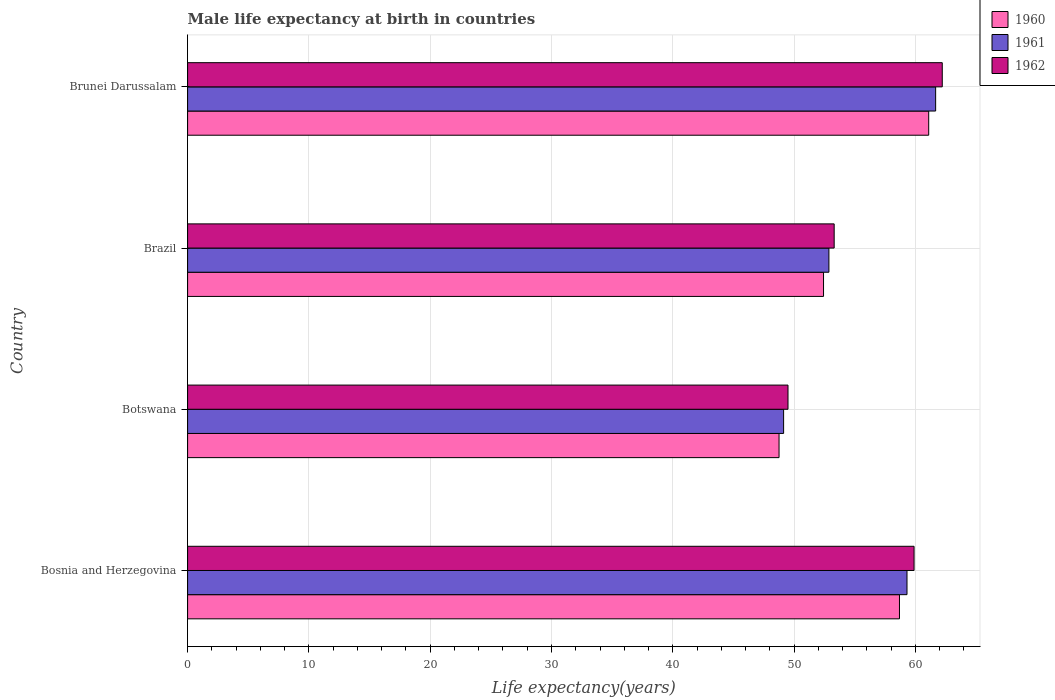How many different coloured bars are there?
Make the answer very short. 3. Are the number of bars on each tick of the Y-axis equal?
Keep it short and to the point. Yes. How many bars are there on the 1st tick from the top?
Offer a terse response. 3. How many bars are there on the 2nd tick from the bottom?
Offer a terse response. 3. What is the label of the 2nd group of bars from the top?
Keep it short and to the point. Brazil. What is the male life expectancy at birth in 1960 in Botswana?
Offer a very short reply. 48.76. Across all countries, what is the maximum male life expectancy at birth in 1960?
Your response must be concise. 61.09. Across all countries, what is the minimum male life expectancy at birth in 1962?
Offer a very short reply. 49.5. In which country was the male life expectancy at birth in 1962 maximum?
Your response must be concise. Brunei Darussalam. In which country was the male life expectancy at birth in 1960 minimum?
Provide a short and direct response. Botswana. What is the total male life expectancy at birth in 1962 in the graph?
Offer a terse response. 224.9. What is the difference between the male life expectancy at birth in 1961 in Bosnia and Herzegovina and that in Brunei Darussalam?
Offer a very short reply. -2.36. What is the difference between the male life expectancy at birth in 1960 in Brunei Darussalam and the male life expectancy at birth in 1961 in Brazil?
Ensure brevity in your answer.  8.23. What is the average male life expectancy at birth in 1960 per country?
Provide a succinct answer. 55.24. What is the difference between the male life expectancy at birth in 1961 and male life expectancy at birth in 1962 in Bosnia and Herzegovina?
Your answer should be very brief. -0.58. What is the ratio of the male life expectancy at birth in 1960 in Brazil to that in Brunei Darussalam?
Your answer should be compact. 0.86. What is the difference between the highest and the second highest male life expectancy at birth in 1960?
Your answer should be very brief. 2.41. What is the difference between the highest and the lowest male life expectancy at birth in 1961?
Make the answer very short. 12.53. In how many countries, is the male life expectancy at birth in 1960 greater than the average male life expectancy at birth in 1960 taken over all countries?
Offer a very short reply. 2. Is the sum of the male life expectancy at birth in 1962 in Brazil and Brunei Darussalam greater than the maximum male life expectancy at birth in 1961 across all countries?
Give a very brief answer. Yes. What does the 2nd bar from the bottom in Brunei Darussalam represents?
Provide a short and direct response. 1961. Are the values on the major ticks of X-axis written in scientific E-notation?
Ensure brevity in your answer.  No. How are the legend labels stacked?
Give a very brief answer. Vertical. What is the title of the graph?
Make the answer very short. Male life expectancy at birth in countries. What is the label or title of the X-axis?
Give a very brief answer. Life expectancy(years). What is the label or title of the Y-axis?
Your answer should be very brief. Country. What is the Life expectancy(years) of 1960 in Bosnia and Herzegovina?
Offer a very short reply. 58.69. What is the Life expectancy(years) of 1961 in Bosnia and Herzegovina?
Your answer should be very brief. 59.3. What is the Life expectancy(years) in 1962 in Bosnia and Herzegovina?
Your answer should be very brief. 59.89. What is the Life expectancy(years) of 1960 in Botswana?
Keep it short and to the point. 48.76. What is the Life expectancy(years) of 1961 in Botswana?
Make the answer very short. 49.13. What is the Life expectancy(years) of 1962 in Botswana?
Your answer should be very brief. 49.5. What is the Life expectancy(years) in 1960 in Brazil?
Your answer should be very brief. 52.42. What is the Life expectancy(years) of 1961 in Brazil?
Ensure brevity in your answer.  52.87. What is the Life expectancy(years) of 1962 in Brazil?
Your answer should be compact. 53.3. What is the Life expectancy(years) in 1960 in Brunei Darussalam?
Provide a succinct answer. 61.09. What is the Life expectancy(years) in 1961 in Brunei Darussalam?
Provide a short and direct response. 61.67. What is the Life expectancy(years) of 1962 in Brunei Darussalam?
Ensure brevity in your answer.  62.21. Across all countries, what is the maximum Life expectancy(years) in 1960?
Provide a short and direct response. 61.09. Across all countries, what is the maximum Life expectancy(years) of 1961?
Keep it short and to the point. 61.67. Across all countries, what is the maximum Life expectancy(years) of 1962?
Offer a very short reply. 62.21. Across all countries, what is the minimum Life expectancy(years) of 1960?
Ensure brevity in your answer.  48.76. Across all countries, what is the minimum Life expectancy(years) in 1961?
Offer a very short reply. 49.13. Across all countries, what is the minimum Life expectancy(years) of 1962?
Ensure brevity in your answer.  49.5. What is the total Life expectancy(years) of 1960 in the graph?
Offer a very short reply. 220.96. What is the total Life expectancy(years) in 1961 in the graph?
Keep it short and to the point. 222.97. What is the total Life expectancy(years) of 1962 in the graph?
Give a very brief answer. 224.9. What is the difference between the Life expectancy(years) of 1960 in Bosnia and Herzegovina and that in Botswana?
Offer a terse response. 9.93. What is the difference between the Life expectancy(years) in 1961 in Bosnia and Herzegovina and that in Botswana?
Keep it short and to the point. 10.17. What is the difference between the Life expectancy(years) in 1962 in Bosnia and Herzegovina and that in Botswana?
Your response must be concise. 10.39. What is the difference between the Life expectancy(years) of 1960 in Bosnia and Herzegovina and that in Brazil?
Offer a terse response. 6.26. What is the difference between the Life expectancy(years) of 1961 in Bosnia and Herzegovina and that in Brazil?
Ensure brevity in your answer.  6.44. What is the difference between the Life expectancy(years) in 1962 in Bosnia and Herzegovina and that in Brazil?
Offer a very short reply. 6.58. What is the difference between the Life expectancy(years) of 1960 in Bosnia and Herzegovina and that in Brunei Darussalam?
Keep it short and to the point. -2.41. What is the difference between the Life expectancy(years) in 1961 in Bosnia and Herzegovina and that in Brunei Darussalam?
Ensure brevity in your answer.  -2.36. What is the difference between the Life expectancy(years) of 1962 in Bosnia and Herzegovina and that in Brunei Darussalam?
Provide a short and direct response. -2.33. What is the difference between the Life expectancy(years) in 1960 in Botswana and that in Brazil?
Offer a very short reply. -3.67. What is the difference between the Life expectancy(years) of 1961 in Botswana and that in Brazil?
Your response must be concise. -3.73. What is the difference between the Life expectancy(years) of 1962 in Botswana and that in Brazil?
Ensure brevity in your answer.  -3.81. What is the difference between the Life expectancy(years) of 1960 in Botswana and that in Brunei Darussalam?
Keep it short and to the point. -12.34. What is the difference between the Life expectancy(years) in 1961 in Botswana and that in Brunei Darussalam?
Give a very brief answer. -12.53. What is the difference between the Life expectancy(years) in 1962 in Botswana and that in Brunei Darussalam?
Ensure brevity in your answer.  -12.72. What is the difference between the Life expectancy(years) of 1960 in Brazil and that in Brunei Darussalam?
Your answer should be compact. -8.67. What is the difference between the Life expectancy(years) in 1961 in Brazil and that in Brunei Darussalam?
Your answer should be compact. -8.8. What is the difference between the Life expectancy(years) in 1962 in Brazil and that in Brunei Darussalam?
Provide a succinct answer. -8.91. What is the difference between the Life expectancy(years) of 1960 in Bosnia and Herzegovina and the Life expectancy(years) of 1961 in Botswana?
Keep it short and to the point. 9.55. What is the difference between the Life expectancy(years) of 1960 in Bosnia and Herzegovina and the Life expectancy(years) of 1962 in Botswana?
Offer a very short reply. 9.19. What is the difference between the Life expectancy(years) in 1961 in Bosnia and Herzegovina and the Life expectancy(years) in 1962 in Botswana?
Offer a very short reply. 9.81. What is the difference between the Life expectancy(years) in 1960 in Bosnia and Herzegovina and the Life expectancy(years) in 1961 in Brazil?
Keep it short and to the point. 5.82. What is the difference between the Life expectancy(years) of 1960 in Bosnia and Herzegovina and the Life expectancy(years) of 1962 in Brazil?
Your response must be concise. 5.38. What is the difference between the Life expectancy(years) of 1961 in Bosnia and Herzegovina and the Life expectancy(years) of 1962 in Brazil?
Your response must be concise. 6. What is the difference between the Life expectancy(years) of 1960 in Bosnia and Herzegovina and the Life expectancy(years) of 1961 in Brunei Darussalam?
Keep it short and to the point. -2.98. What is the difference between the Life expectancy(years) in 1960 in Bosnia and Herzegovina and the Life expectancy(years) in 1962 in Brunei Darussalam?
Your answer should be compact. -3.53. What is the difference between the Life expectancy(years) in 1961 in Bosnia and Herzegovina and the Life expectancy(years) in 1962 in Brunei Darussalam?
Make the answer very short. -2.91. What is the difference between the Life expectancy(years) of 1960 in Botswana and the Life expectancy(years) of 1961 in Brazil?
Your answer should be very brief. -4.11. What is the difference between the Life expectancy(years) of 1960 in Botswana and the Life expectancy(years) of 1962 in Brazil?
Your answer should be compact. -4.54. What is the difference between the Life expectancy(years) of 1961 in Botswana and the Life expectancy(years) of 1962 in Brazil?
Offer a terse response. -4.17. What is the difference between the Life expectancy(years) of 1960 in Botswana and the Life expectancy(years) of 1961 in Brunei Darussalam?
Your answer should be very brief. -12.91. What is the difference between the Life expectancy(years) of 1960 in Botswana and the Life expectancy(years) of 1962 in Brunei Darussalam?
Provide a short and direct response. -13.46. What is the difference between the Life expectancy(years) in 1961 in Botswana and the Life expectancy(years) in 1962 in Brunei Darussalam?
Offer a very short reply. -13.08. What is the difference between the Life expectancy(years) in 1960 in Brazil and the Life expectancy(years) in 1961 in Brunei Darussalam?
Your answer should be compact. -9.24. What is the difference between the Life expectancy(years) of 1960 in Brazil and the Life expectancy(years) of 1962 in Brunei Darussalam?
Give a very brief answer. -9.79. What is the difference between the Life expectancy(years) in 1961 in Brazil and the Life expectancy(years) in 1962 in Brunei Darussalam?
Offer a very short reply. -9.35. What is the average Life expectancy(years) in 1960 per country?
Your answer should be very brief. 55.24. What is the average Life expectancy(years) in 1961 per country?
Offer a very short reply. 55.74. What is the average Life expectancy(years) in 1962 per country?
Provide a short and direct response. 56.22. What is the difference between the Life expectancy(years) of 1960 and Life expectancy(years) of 1961 in Bosnia and Herzegovina?
Keep it short and to the point. -0.62. What is the difference between the Life expectancy(years) in 1960 and Life expectancy(years) in 1962 in Bosnia and Herzegovina?
Your response must be concise. -1.2. What is the difference between the Life expectancy(years) of 1961 and Life expectancy(years) of 1962 in Bosnia and Herzegovina?
Provide a succinct answer. -0.58. What is the difference between the Life expectancy(years) of 1960 and Life expectancy(years) of 1961 in Botswana?
Provide a short and direct response. -0.38. What is the difference between the Life expectancy(years) of 1960 and Life expectancy(years) of 1962 in Botswana?
Your response must be concise. -0.74. What is the difference between the Life expectancy(years) in 1961 and Life expectancy(years) in 1962 in Botswana?
Ensure brevity in your answer.  -0.36. What is the difference between the Life expectancy(years) of 1960 and Life expectancy(years) of 1961 in Brazil?
Offer a terse response. -0.44. What is the difference between the Life expectancy(years) in 1960 and Life expectancy(years) in 1962 in Brazil?
Ensure brevity in your answer.  -0.88. What is the difference between the Life expectancy(years) of 1961 and Life expectancy(years) of 1962 in Brazil?
Your answer should be compact. -0.43. What is the difference between the Life expectancy(years) of 1960 and Life expectancy(years) of 1961 in Brunei Darussalam?
Your answer should be very brief. -0.57. What is the difference between the Life expectancy(years) in 1960 and Life expectancy(years) in 1962 in Brunei Darussalam?
Provide a short and direct response. -1.12. What is the difference between the Life expectancy(years) in 1961 and Life expectancy(years) in 1962 in Brunei Darussalam?
Offer a very short reply. -0.55. What is the ratio of the Life expectancy(years) of 1960 in Bosnia and Herzegovina to that in Botswana?
Your answer should be compact. 1.2. What is the ratio of the Life expectancy(years) of 1961 in Bosnia and Herzegovina to that in Botswana?
Offer a very short reply. 1.21. What is the ratio of the Life expectancy(years) of 1962 in Bosnia and Herzegovina to that in Botswana?
Your answer should be very brief. 1.21. What is the ratio of the Life expectancy(years) of 1960 in Bosnia and Herzegovina to that in Brazil?
Your answer should be very brief. 1.12. What is the ratio of the Life expectancy(years) of 1961 in Bosnia and Herzegovina to that in Brazil?
Your answer should be very brief. 1.12. What is the ratio of the Life expectancy(years) in 1962 in Bosnia and Herzegovina to that in Brazil?
Give a very brief answer. 1.12. What is the ratio of the Life expectancy(years) in 1960 in Bosnia and Herzegovina to that in Brunei Darussalam?
Give a very brief answer. 0.96. What is the ratio of the Life expectancy(years) of 1961 in Bosnia and Herzegovina to that in Brunei Darussalam?
Provide a succinct answer. 0.96. What is the ratio of the Life expectancy(years) of 1962 in Bosnia and Herzegovina to that in Brunei Darussalam?
Your response must be concise. 0.96. What is the ratio of the Life expectancy(years) of 1960 in Botswana to that in Brazil?
Offer a terse response. 0.93. What is the ratio of the Life expectancy(years) of 1961 in Botswana to that in Brazil?
Your answer should be compact. 0.93. What is the ratio of the Life expectancy(years) in 1962 in Botswana to that in Brazil?
Give a very brief answer. 0.93. What is the ratio of the Life expectancy(years) of 1960 in Botswana to that in Brunei Darussalam?
Keep it short and to the point. 0.8. What is the ratio of the Life expectancy(years) in 1961 in Botswana to that in Brunei Darussalam?
Make the answer very short. 0.8. What is the ratio of the Life expectancy(years) of 1962 in Botswana to that in Brunei Darussalam?
Your response must be concise. 0.8. What is the ratio of the Life expectancy(years) of 1960 in Brazil to that in Brunei Darussalam?
Offer a very short reply. 0.86. What is the ratio of the Life expectancy(years) of 1961 in Brazil to that in Brunei Darussalam?
Provide a succinct answer. 0.86. What is the ratio of the Life expectancy(years) of 1962 in Brazil to that in Brunei Darussalam?
Give a very brief answer. 0.86. What is the difference between the highest and the second highest Life expectancy(years) in 1960?
Your answer should be very brief. 2.41. What is the difference between the highest and the second highest Life expectancy(years) of 1961?
Your answer should be compact. 2.36. What is the difference between the highest and the second highest Life expectancy(years) in 1962?
Your response must be concise. 2.33. What is the difference between the highest and the lowest Life expectancy(years) in 1960?
Ensure brevity in your answer.  12.34. What is the difference between the highest and the lowest Life expectancy(years) of 1961?
Your answer should be very brief. 12.53. What is the difference between the highest and the lowest Life expectancy(years) in 1962?
Offer a very short reply. 12.72. 